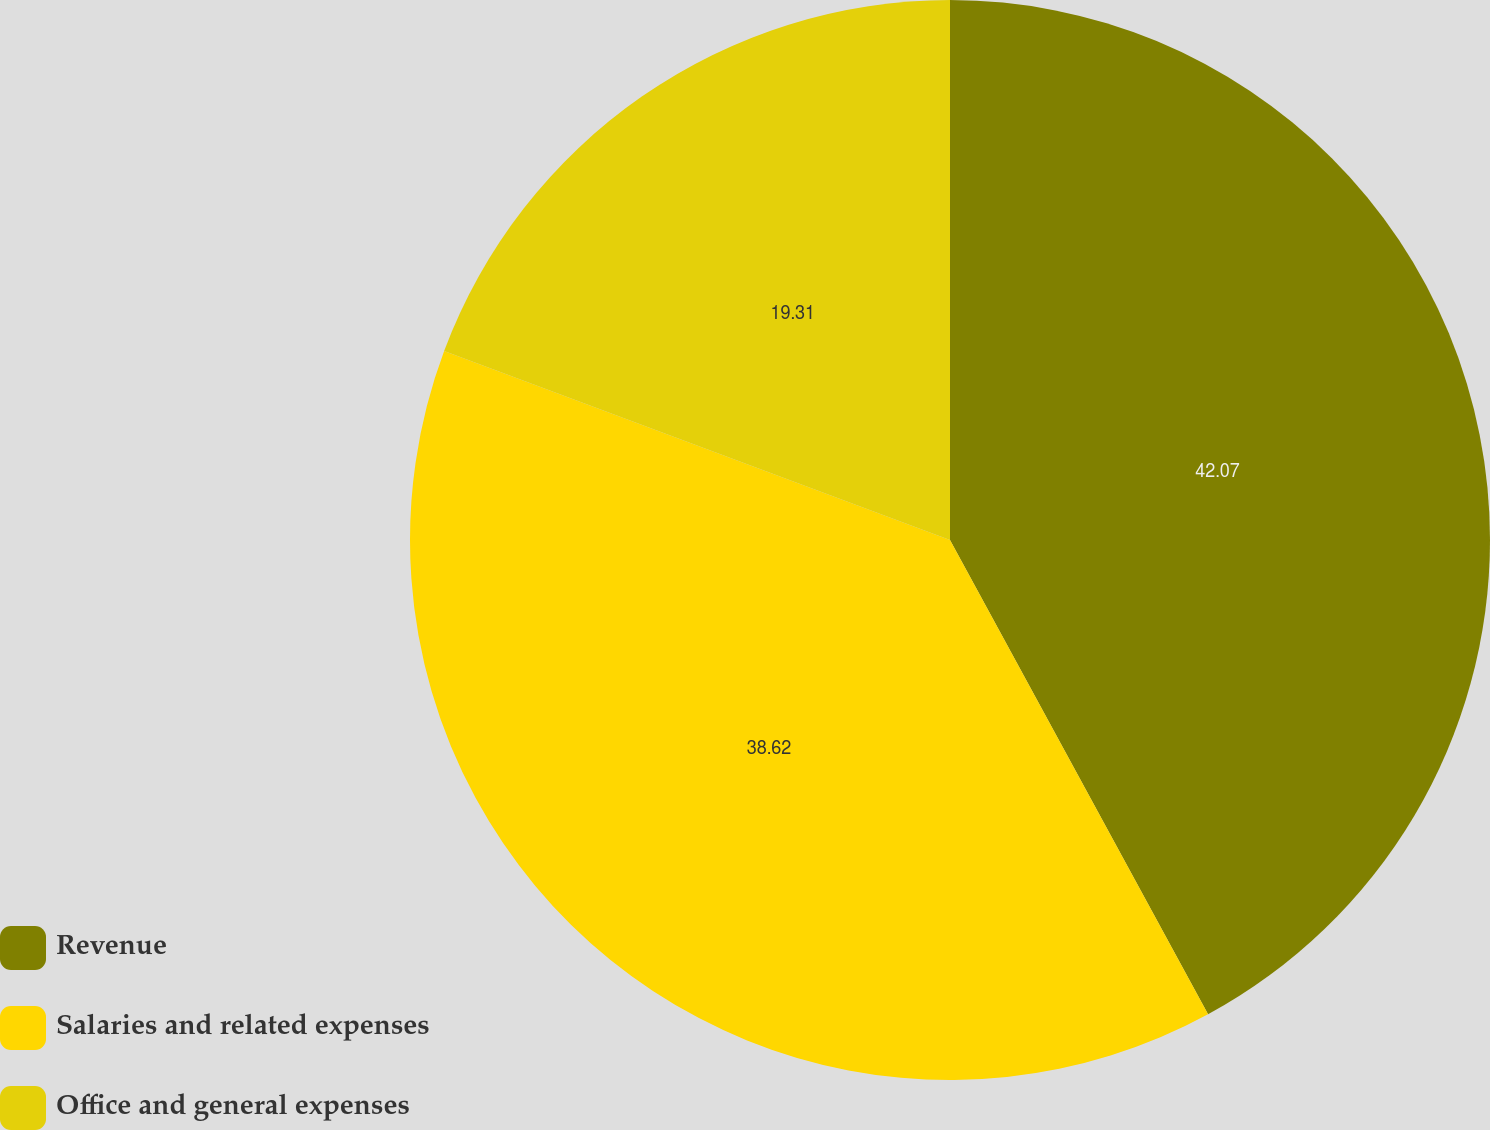Convert chart. <chart><loc_0><loc_0><loc_500><loc_500><pie_chart><fcel>Revenue<fcel>Salaries and related expenses<fcel>Office and general expenses<nl><fcel>42.07%<fcel>38.62%<fcel>19.31%<nl></chart> 